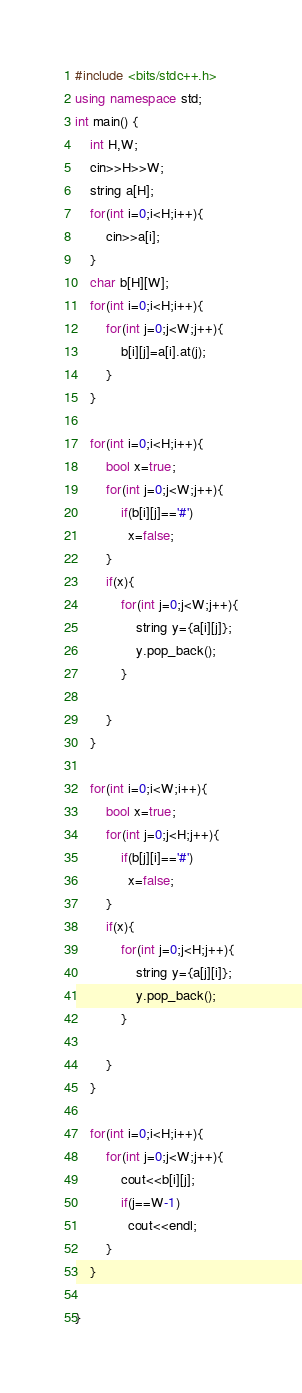Convert code to text. <code><loc_0><loc_0><loc_500><loc_500><_C++_>#include <bits/stdc++.h>
using namespace std;
int main() {
    int H,W;
    cin>>H>>W;
    string a[H];
    for(int i=0;i<H;i++){
        cin>>a[i];
    }
    char b[H][W];
    for(int i=0;i<H;i++){
        for(int j=0;j<W;j++){
            b[i][j]=a[i].at(j);
        }
    }

    for(int i=0;i<H;i++){
        bool x=true;
        for(int j=0;j<W;j++){
            if(b[i][j]=='#')
              x=false;      
        }
        if(x){
            for(int j=0;j<W;j++){
                string y={a[i][j]};
                y.pop_back();
            }

        }
    }

    for(int i=0;i<W;i++){
        bool x=true;
        for(int j=0;j<H;j++){
            if(b[j][i]=='#')
              x=false;      
        }
        if(x){
            for(int j=0;j<H;j++){
                string y={a[j][i]};
                y.pop_back();
            }

        }
    }

    for(int i=0;i<H;i++){
        for(int j=0;j<W;j++){
            cout<<b[i][j];
            if(j==W-1)
              cout<<endl;
        }
    }

}</code> 